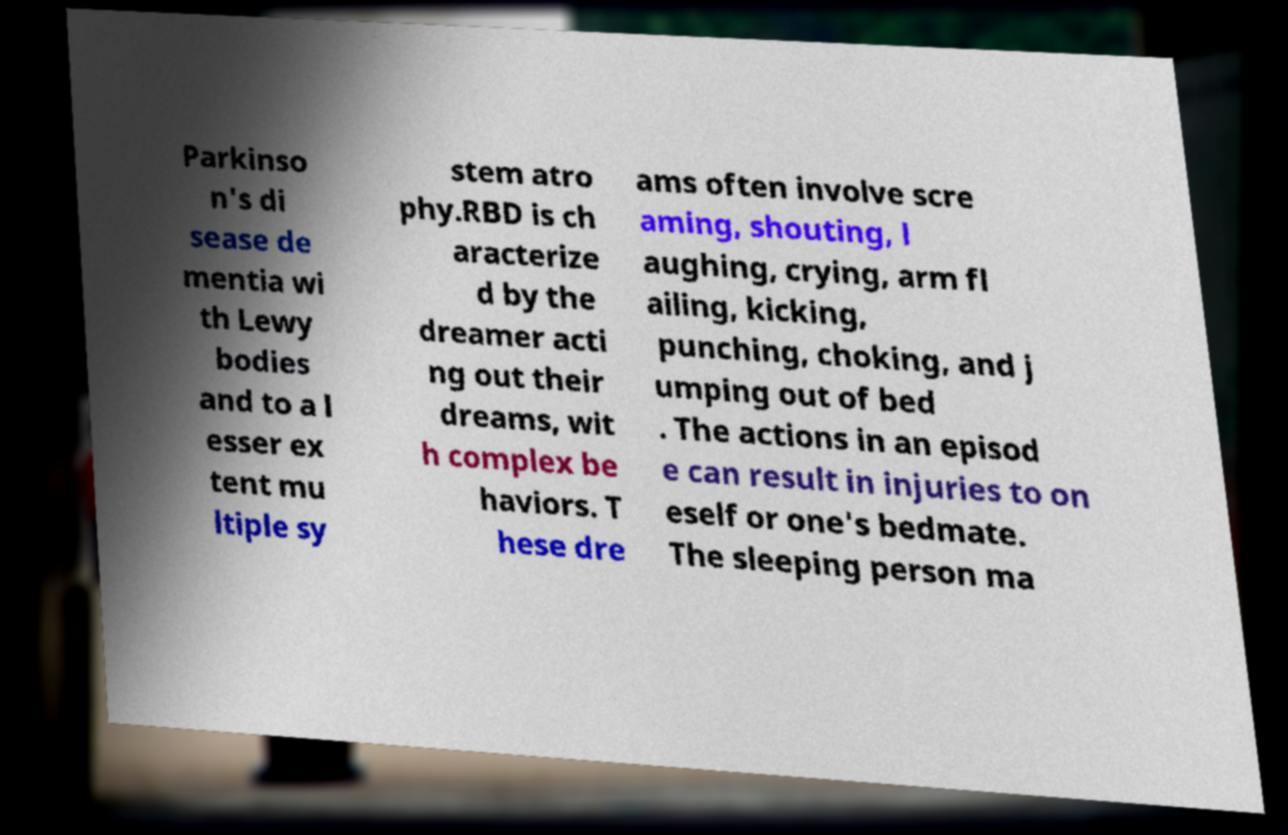What messages or text are displayed in this image? I need them in a readable, typed format. Parkinso n's di sease de mentia wi th Lewy bodies and to a l esser ex tent mu ltiple sy stem atro phy.RBD is ch aracterize d by the dreamer acti ng out their dreams, wit h complex be haviors. T hese dre ams often involve scre aming, shouting, l aughing, crying, arm fl ailing, kicking, punching, choking, and j umping out of bed . The actions in an episod e can result in injuries to on eself or one's bedmate. The sleeping person ma 